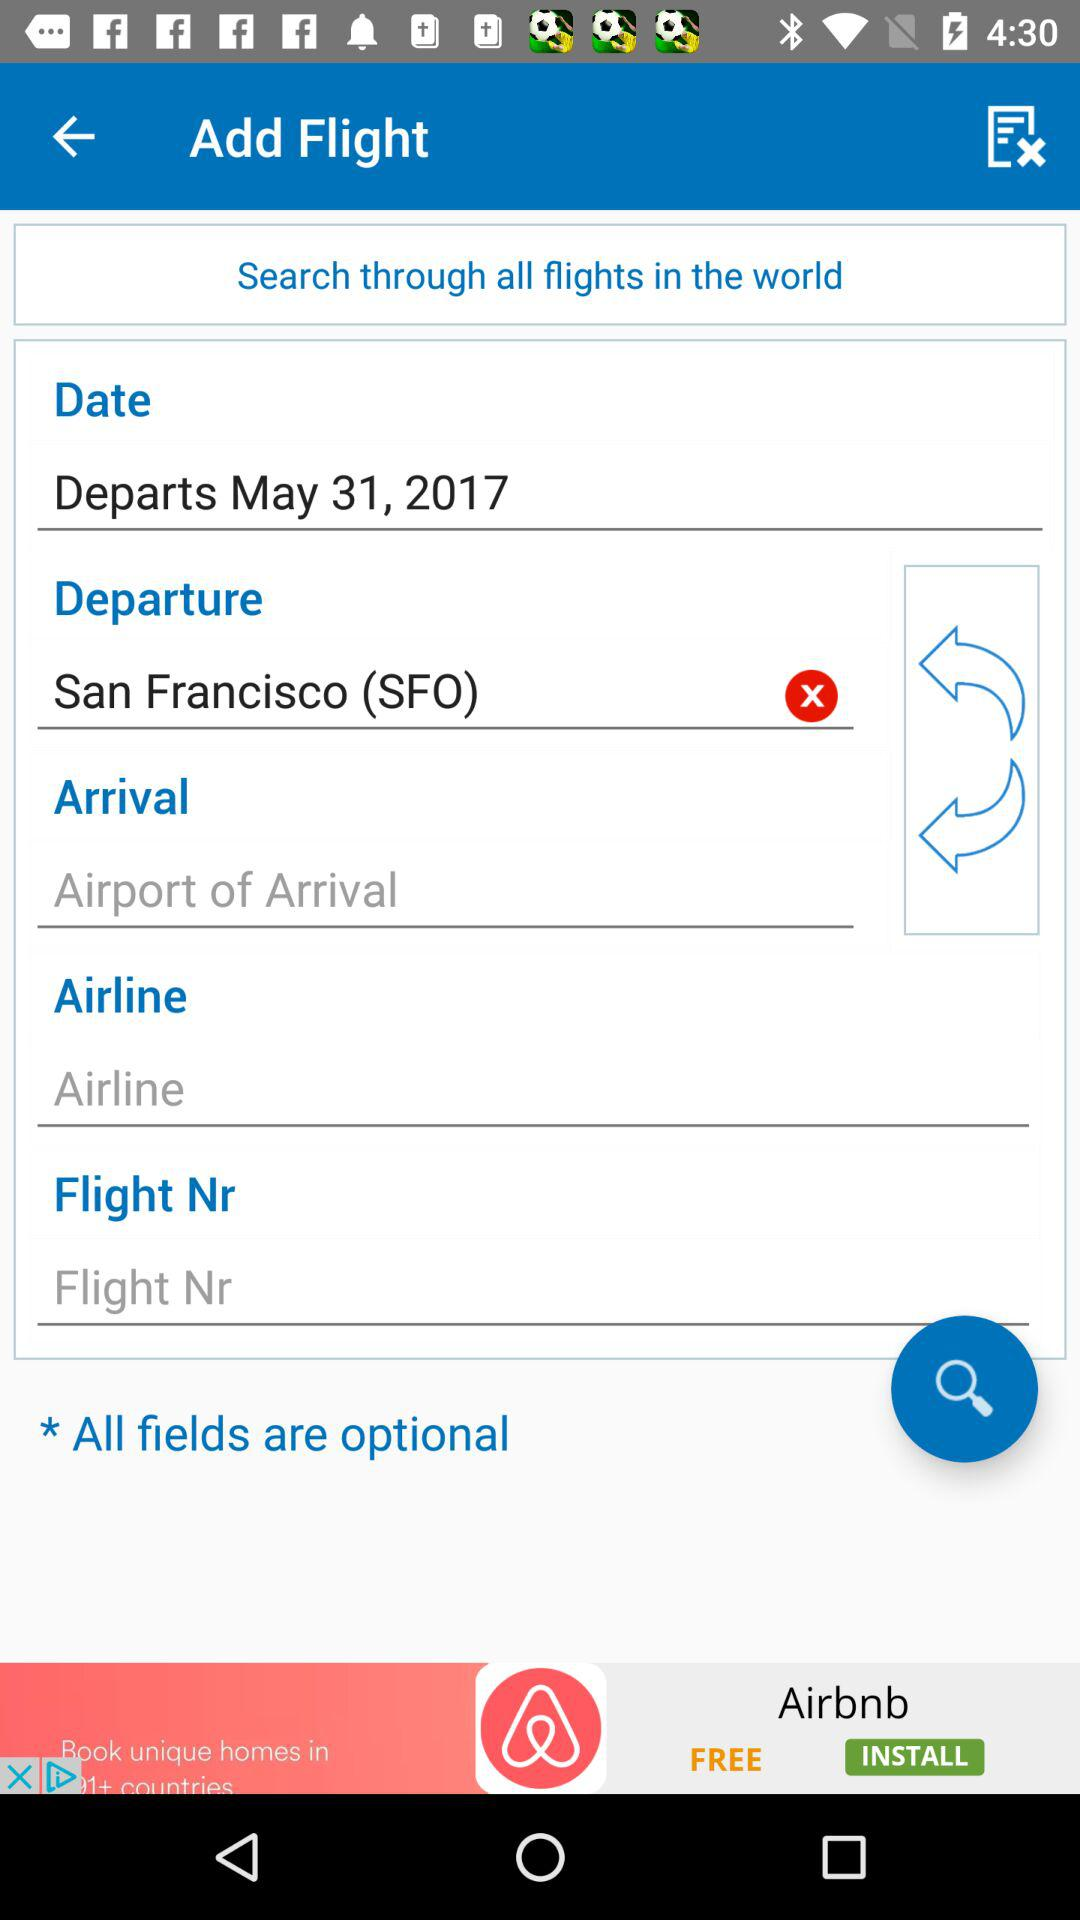What is the departure date? The departure date is May 31, 2017. 